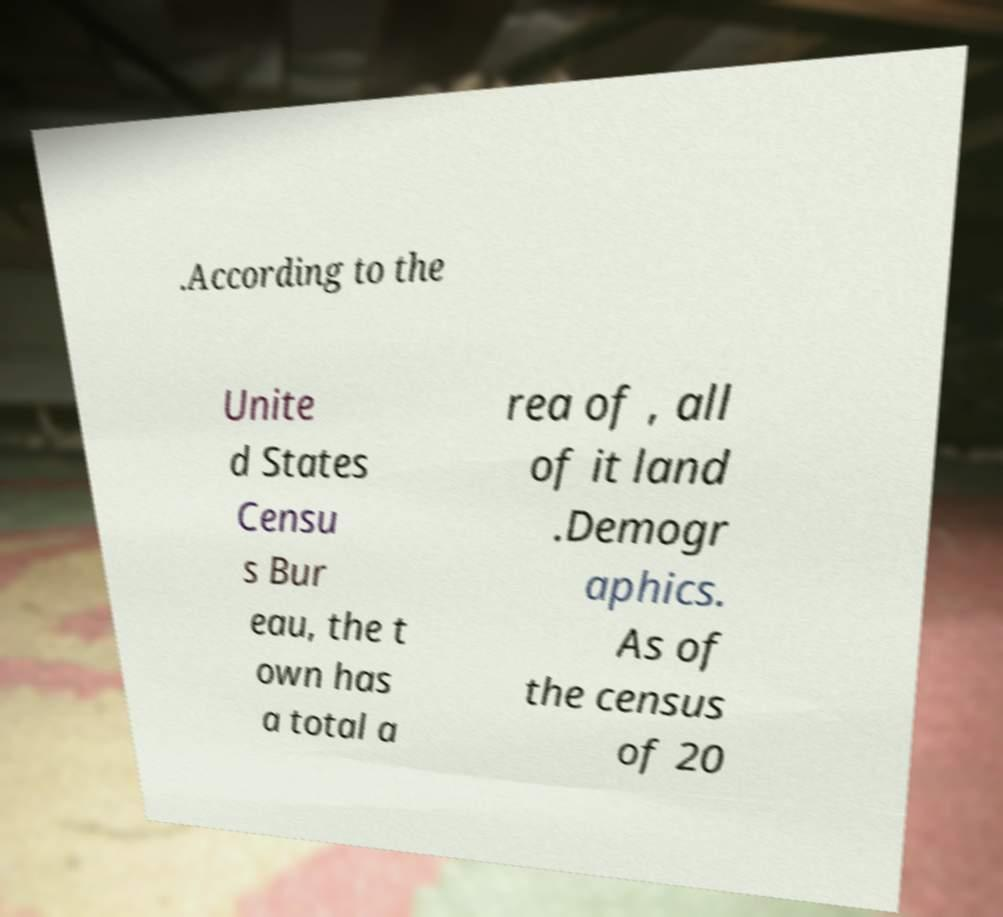I need the written content from this picture converted into text. Can you do that? .According to the Unite d States Censu s Bur eau, the t own has a total a rea of , all of it land .Demogr aphics. As of the census of 20 